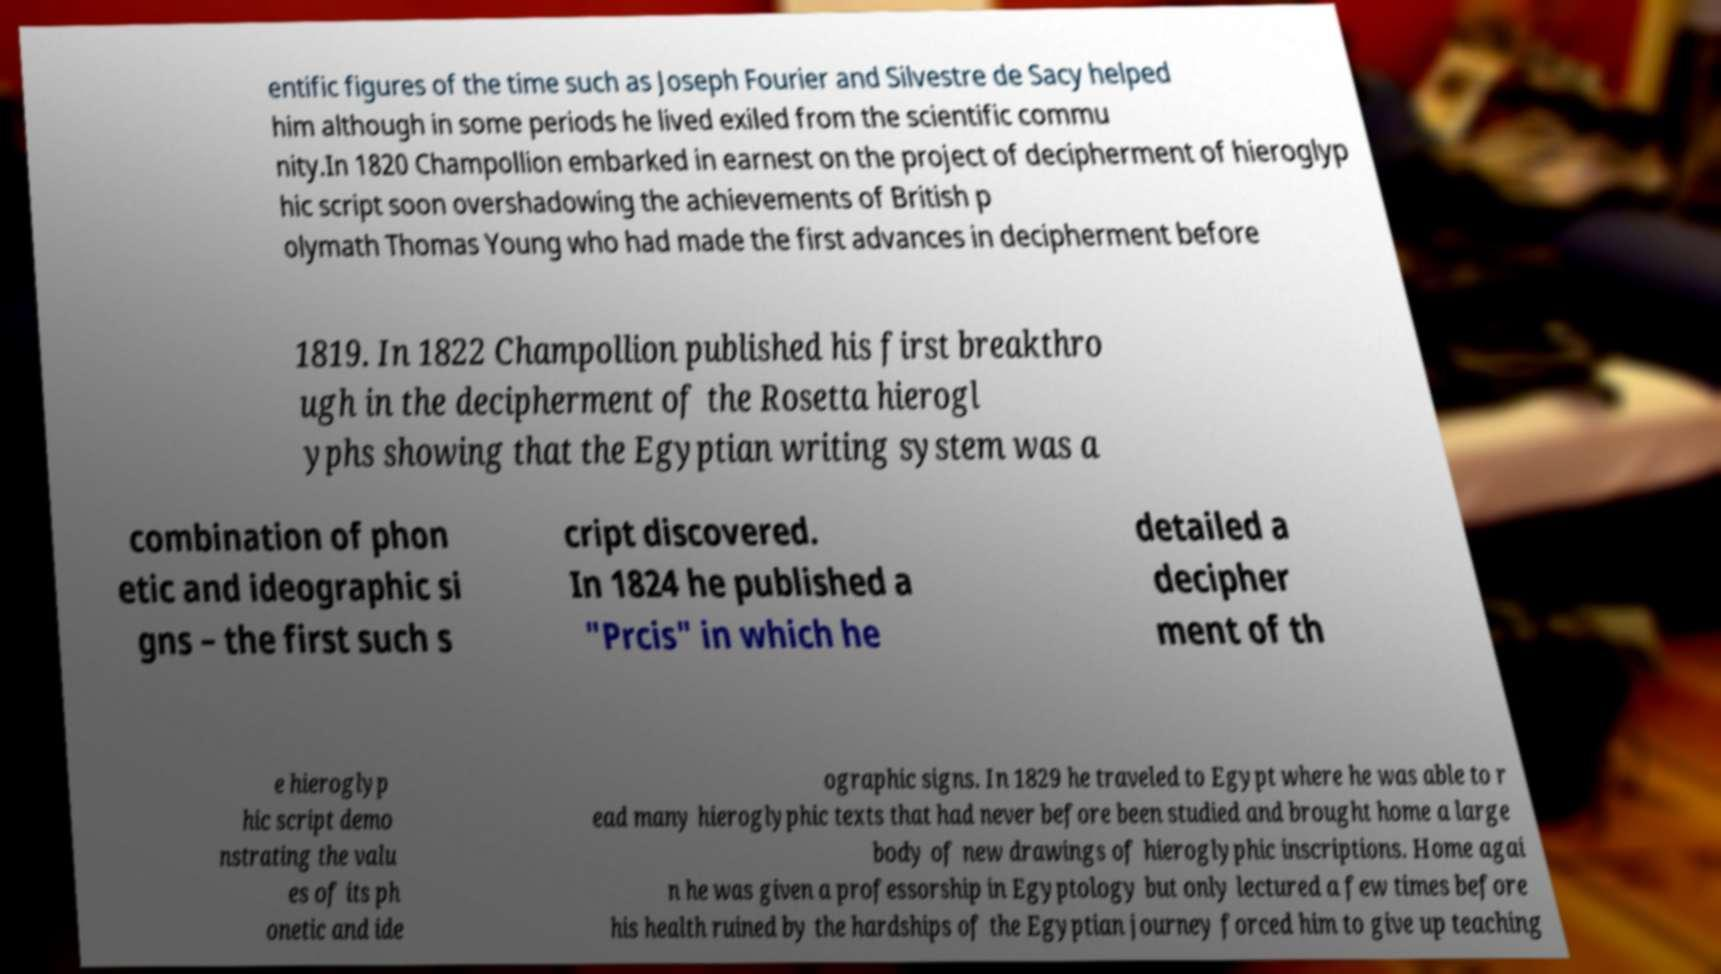Please identify and transcribe the text found in this image. entific figures of the time such as Joseph Fourier and Silvestre de Sacy helped him although in some periods he lived exiled from the scientific commu nity.In 1820 Champollion embarked in earnest on the project of decipherment of hieroglyp hic script soon overshadowing the achievements of British p olymath Thomas Young who had made the first advances in decipherment before 1819. In 1822 Champollion published his first breakthro ugh in the decipherment of the Rosetta hierogl yphs showing that the Egyptian writing system was a combination of phon etic and ideographic si gns – the first such s cript discovered. In 1824 he published a "Prcis" in which he detailed a decipher ment of th e hieroglyp hic script demo nstrating the valu es of its ph onetic and ide ographic signs. In 1829 he traveled to Egypt where he was able to r ead many hieroglyphic texts that had never before been studied and brought home a large body of new drawings of hieroglyphic inscriptions. Home agai n he was given a professorship in Egyptology but only lectured a few times before his health ruined by the hardships of the Egyptian journey forced him to give up teaching 